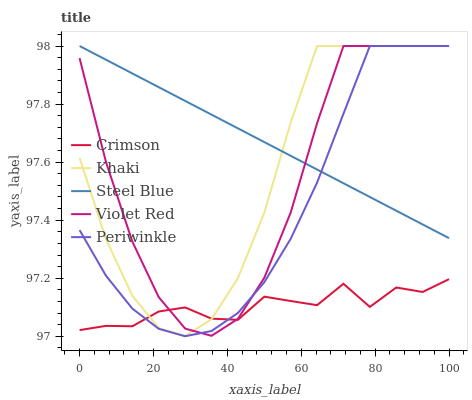Does Crimson have the minimum area under the curve?
Answer yes or no. Yes. Does Steel Blue have the maximum area under the curve?
Answer yes or no. Yes. Does Violet Red have the minimum area under the curve?
Answer yes or no. No. Does Violet Red have the maximum area under the curve?
Answer yes or no. No. Is Steel Blue the smoothest?
Answer yes or no. Yes. Is Violet Red the roughest?
Answer yes or no. Yes. Is Khaki the smoothest?
Answer yes or no. No. Is Khaki the roughest?
Answer yes or no. No. Does Periwinkle have the lowest value?
Answer yes or no. Yes. Does Violet Red have the lowest value?
Answer yes or no. No. Does Steel Blue have the highest value?
Answer yes or no. Yes. Is Crimson less than Steel Blue?
Answer yes or no. Yes. Is Steel Blue greater than Crimson?
Answer yes or no. Yes. Does Steel Blue intersect Khaki?
Answer yes or no. Yes. Is Steel Blue less than Khaki?
Answer yes or no. No. Is Steel Blue greater than Khaki?
Answer yes or no. No. Does Crimson intersect Steel Blue?
Answer yes or no. No. 